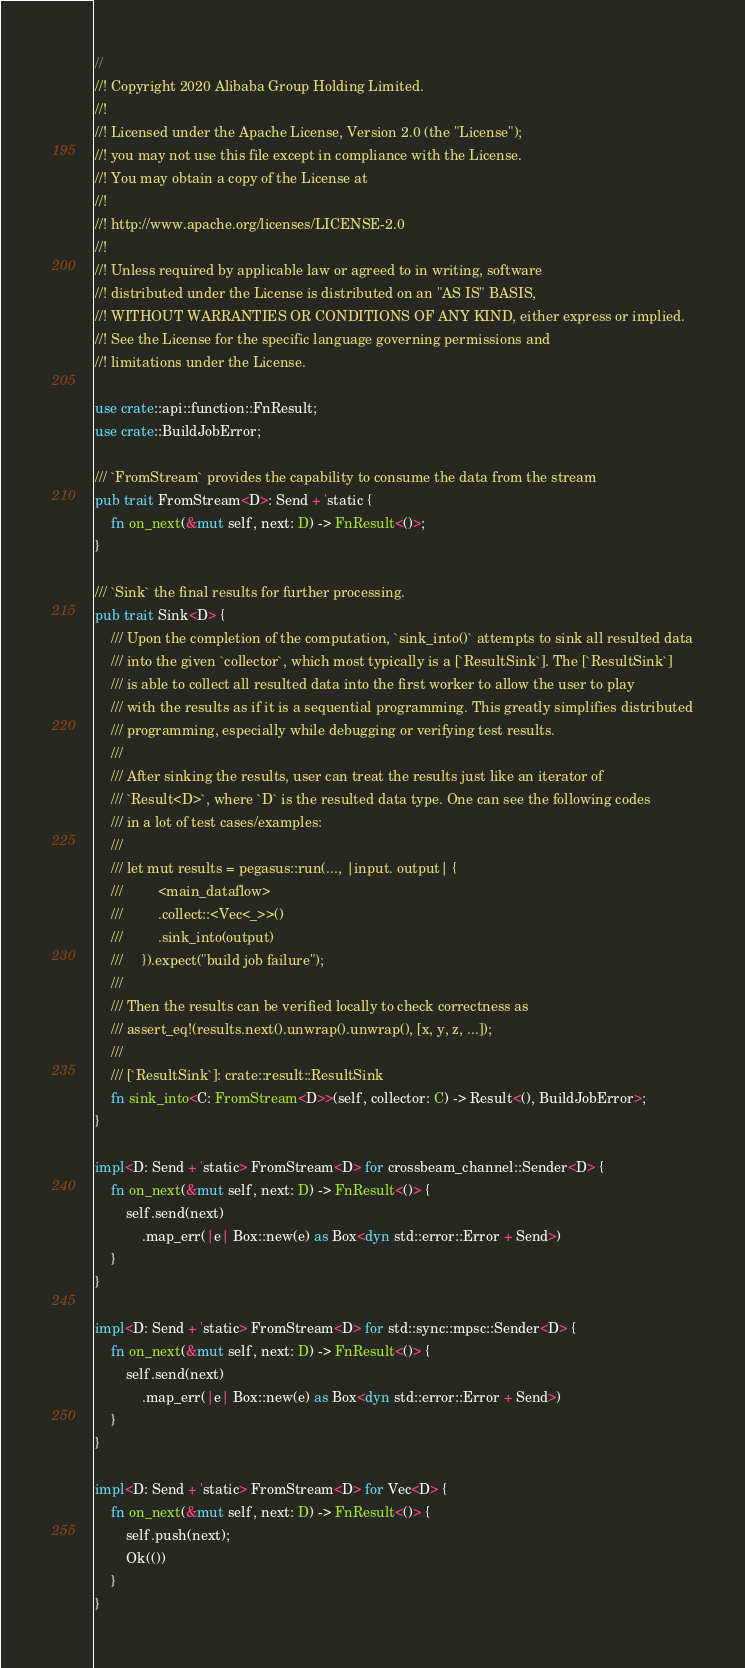Convert code to text. <code><loc_0><loc_0><loc_500><loc_500><_Rust_>//
//! Copyright 2020 Alibaba Group Holding Limited.
//!
//! Licensed under the Apache License, Version 2.0 (the "License");
//! you may not use this file except in compliance with the License.
//! You may obtain a copy of the License at
//!
//! http://www.apache.org/licenses/LICENSE-2.0
//!
//! Unless required by applicable law or agreed to in writing, software
//! distributed under the License is distributed on an "AS IS" BASIS,
//! WITHOUT WARRANTIES OR CONDITIONS OF ANY KIND, either express or implied.
//! See the License for the specific language governing permissions and
//! limitations under the License.

use crate::api::function::FnResult;
use crate::BuildJobError;

/// `FromStream` provides the capability to consume the data from the stream
pub trait FromStream<D>: Send + 'static {
    fn on_next(&mut self, next: D) -> FnResult<()>;
}

/// `Sink` the final results for further processing.  
pub trait Sink<D> {
    /// Upon the completion of the computation, `sink_into()` attempts to sink all resulted data
    /// into the given `collector`, which most typically is a [`ResultSink`]. The [`ResultSink`]
    /// is able to collect all resulted data into the first worker to allow the user to play
    /// with the results as if it is a sequential programming. This greatly simplifies distributed
    /// programming, especially while debugging or verifying test results.
    ///
    /// After sinking the results, user can treat the results just like an iterator of
    /// `Result<D>`, where `D` is the resulted data type. One can see the following codes
    /// in a lot of test cases/examples:
    ///
    /// let mut results = pegasus::run(..., |input. output| {
    ///         <main_dataflow>
    ///         .collect::<Vec<_>>()
    ///         .sink_into(output)
    ///     }).expect("build job failure");
    ///
    /// Then the results can be verified locally to check correctness as
    /// assert_eq!(results.next().unwrap().unwrap(), [x, y, z, ...]);
    ///
    /// [`ResultSink`]: crate::result::ResultSink
    fn sink_into<C: FromStream<D>>(self, collector: C) -> Result<(), BuildJobError>;
}

impl<D: Send + 'static> FromStream<D> for crossbeam_channel::Sender<D> {
    fn on_next(&mut self, next: D) -> FnResult<()> {
        self.send(next)
            .map_err(|e| Box::new(e) as Box<dyn std::error::Error + Send>)
    }
}

impl<D: Send + 'static> FromStream<D> for std::sync::mpsc::Sender<D> {
    fn on_next(&mut self, next: D) -> FnResult<()> {
        self.send(next)
            .map_err(|e| Box::new(e) as Box<dyn std::error::Error + Send>)
    }
}

impl<D: Send + 'static> FromStream<D> for Vec<D> {
    fn on_next(&mut self, next: D) -> FnResult<()> {
        self.push(next);
        Ok(())
    }
}
</code> 